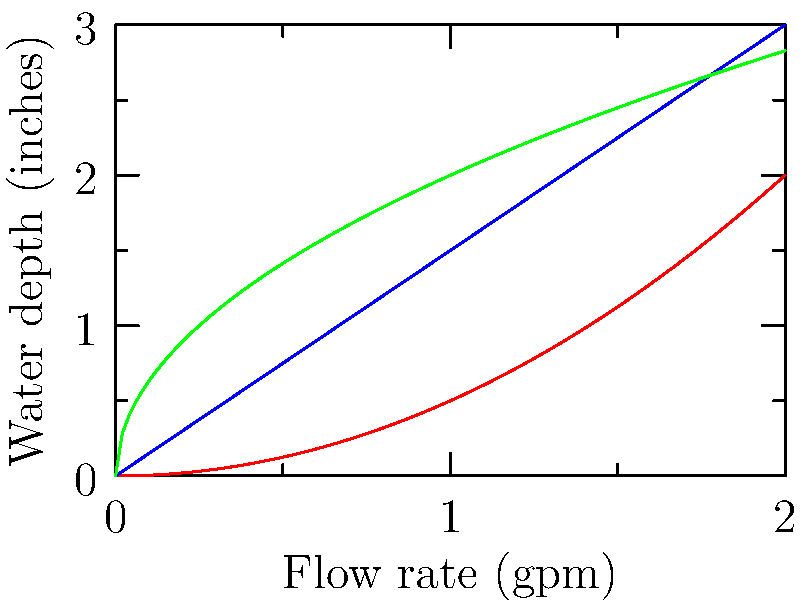Based on the graph showing the relationship between flow rate and water depth for different gutter profiles, which gutter type would be most efficient for areas with sudden, intense rainfall, common in Florida? To determine the most efficient gutter type for areas with sudden, intense rainfall, we need to analyze the graph:

1. The graph shows three gutter profiles: K-style (red), Half-round (blue), and Box (green).

2. The x-axis represents the flow rate in gallons per minute (gpm), while the y-axis shows the water depth in inches.

3. For efficient drainage during intense rainfall, we want a gutter that can handle a high flow rate with minimal water depth accumulation.

4. Analyzing each profile:
   a) K-style (red): Shows a parabolic curve, indicating that water depth increases rapidly as flow rate increases.
   b) Half-round (blue): Shows a linear relationship, with water depth increasing steadily with flow rate.
   c) Box (green): Shows a curve that flattens out, meaning it can handle higher flow rates with less increase in water depth.

5. The Box gutter (green) has the shallowest slope at higher flow rates, indicating it can manage more water with less depth accumulation.

6. This characteristic is crucial for areas like Florida, where sudden, intense rainfall can occur, as it reduces the risk of overflow and water damage.

Therefore, the Box gutter profile would be the most efficient for areas with sudden, intense rainfall, such as Florida.
Answer: Box gutter 